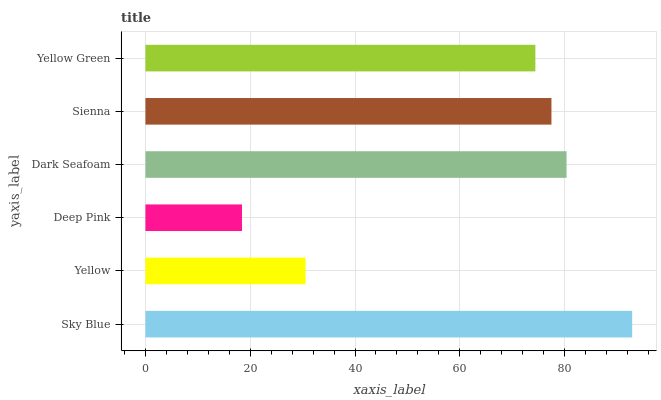Is Deep Pink the minimum?
Answer yes or no. Yes. Is Sky Blue the maximum?
Answer yes or no. Yes. Is Yellow the minimum?
Answer yes or no. No. Is Yellow the maximum?
Answer yes or no. No. Is Sky Blue greater than Yellow?
Answer yes or no. Yes. Is Yellow less than Sky Blue?
Answer yes or no. Yes. Is Yellow greater than Sky Blue?
Answer yes or no. No. Is Sky Blue less than Yellow?
Answer yes or no. No. Is Sienna the high median?
Answer yes or no. Yes. Is Yellow Green the low median?
Answer yes or no. Yes. Is Yellow the high median?
Answer yes or no. No. Is Sienna the low median?
Answer yes or no. No. 